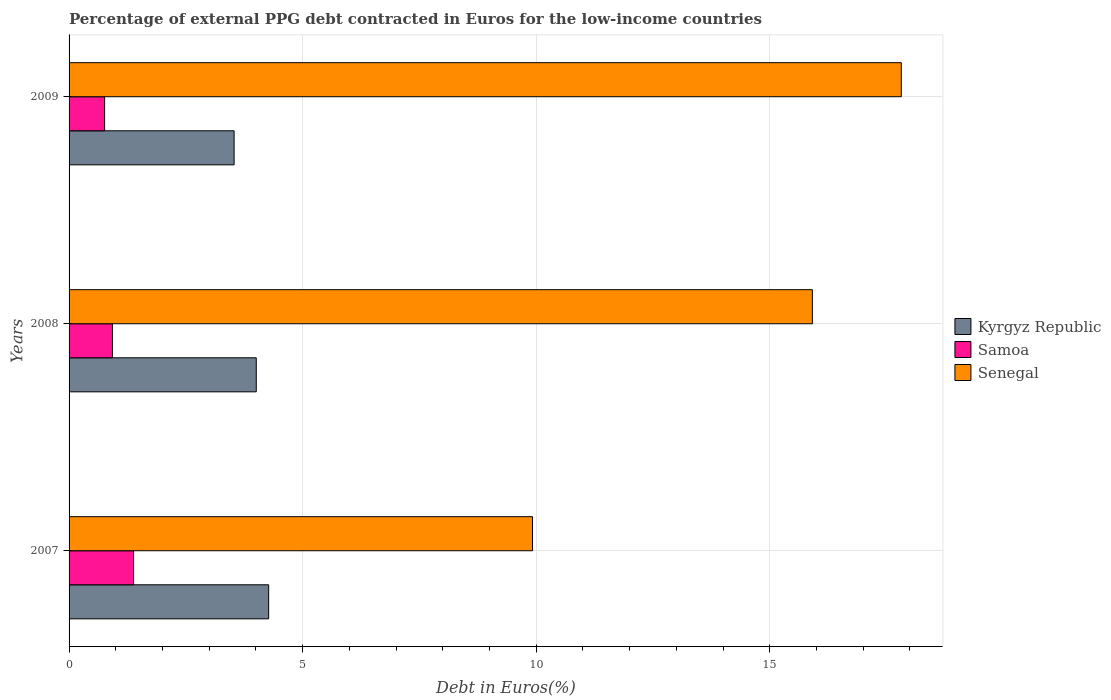How many groups of bars are there?
Offer a very short reply. 3. Are the number of bars per tick equal to the number of legend labels?
Provide a short and direct response. Yes. How many bars are there on the 2nd tick from the top?
Provide a short and direct response. 3. What is the label of the 1st group of bars from the top?
Your answer should be compact. 2009. In how many cases, is the number of bars for a given year not equal to the number of legend labels?
Offer a very short reply. 0. What is the percentage of external PPG debt contracted in Euros in Samoa in 2009?
Offer a terse response. 0.76. Across all years, what is the maximum percentage of external PPG debt contracted in Euros in Senegal?
Provide a succinct answer. 17.81. Across all years, what is the minimum percentage of external PPG debt contracted in Euros in Samoa?
Ensure brevity in your answer.  0.76. In which year was the percentage of external PPG debt contracted in Euros in Senegal minimum?
Your answer should be compact. 2007. What is the total percentage of external PPG debt contracted in Euros in Kyrgyz Republic in the graph?
Your response must be concise. 11.81. What is the difference between the percentage of external PPG debt contracted in Euros in Senegal in 2007 and that in 2008?
Make the answer very short. -5.99. What is the difference between the percentage of external PPG debt contracted in Euros in Kyrgyz Republic in 2009 and the percentage of external PPG debt contracted in Euros in Samoa in 2008?
Offer a very short reply. 2.6. What is the average percentage of external PPG debt contracted in Euros in Senegal per year?
Offer a terse response. 14.55. In the year 2007, what is the difference between the percentage of external PPG debt contracted in Euros in Senegal and percentage of external PPG debt contracted in Euros in Kyrgyz Republic?
Ensure brevity in your answer.  5.65. In how many years, is the percentage of external PPG debt contracted in Euros in Senegal greater than 5 %?
Provide a short and direct response. 3. What is the ratio of the percentage of external PPG debt contracted in Euros in Samoa in 2007 to that in 2009?
Your response must be concise. 1.82. What is the difference between the highest and the second highest percentage of external PPG debt contracted in Euros in Senegal?
Provide a succinct answer. 1.9. What is the difference between the highest and the lowest percentage of external PPG debt contracted in Euros in Samoa?
Keep it short and to the point. 0.62. In how many years, is the percentage of external PPG debt contracted in Euros in Senegal greater than the average percentage of external PPG debt contracted in Euros in Senegal taken over all years?
Ensure brevity in your answer.  2. Is the sum of the percentage of external PPG debt contracted in Euros in Kyrgyz Republic in 2007 and 2008 greater than the maximum percentage of external PPG debt contracted in Euros in Samoa across all years?
Make the answer very short. Yes. What does the 2nd bar from the top in 2009 represents?
Offer a terse response. Samoa. What does the 1st bar from the bottom in 2009 represents?
Give a very brief answer. Kyrgyz Republic. Is it the case that in every year, the sum of the percentage of external PPG debt contracted in Euros in Samoa and percentage of external PPG debt contracted in Euros in Senegal is greater than the percentage of external PPG debt contracted in Euros in Kyrgyz Republic?
Provide a succinct answer. Yes. How many bars are there?
Ensure brevity in your answer.  9. How many years are there in the graph?
Provide a short and direct response. 3. What is the difference between two consecutive major ticks on the X-axis?
Keep it short and to the point. 5. Does the graph contain grids?
Provide a succinct answer. Yes. Where does the legend appear in the graph?
Offer a very short reply. Center right. What is the title of the graph?
Provide a succinct answer. Percentage of external PPG debt contracted in Euros for the low-income countries. Does "Europe(all income levels)" appear as one of the legend labels in the graph?
Provide a succinct answer. No. What is the label or title of the X-axis?
Offer a very short reply. Debt in Euros(%). What is the label or title of the Y-axis?
Offer a terse response. Years. What is the Debt in Euros(%) in Kyrgyz Republic in 2007?
Give a very brief answer. 4.27. What is the Debt in Euros(%) in Samoa in 2007?
Your answer should be compact. 1.38. What is the Debt in Euros(%) of Senegal in 2007?
Ensure brevity in your answer.  9.92. What is the Debt in Euros(%) in Kyrgyz Republic in 2008?
Ensure brevity in your answer.  4.01. What is the Debt in Euros(%) of Samoa in 2008?
Ensure brevity in your answer.  0.93. What is the Debt in Euros(%) in Senegal in 2008?
Ensure brevity in your answer.  15.91. What is the Debt in Euros(%) in Kyrgyz Republic in 2009?
Keep it short and to the point. 3.53. What is the Debt in Euros(%) of Samoa in 2009?
Provide a short and direct response. 0.76. What is the Debt in Euros(%) of Senegal in 2009?
Offer a terse response. 17.81. Across all years, what is the maximum Debt in Euros(%) in Kyrgyz Republic?
Provide a short and direct response. 4.27. Across all years, what is the maximum Debt in Euros(%) in Samoa?
Keep it short and to the point. 1.38. Across all years, what is the maximum Debt in Euros(%) in Senegal?
Make the answer very short. 17.81. Across all years, what is the minimum Debt in Euros(%) in Kyrgyz Republic?
Give a very brief answer. 3.53. Across all years, what is the minimum Debt in Euros(%) of Samoa?
Ensure brevity in your answer.  0.76. Across all years, what is the minimum Debt in Euros(%) of Senegal?
Offer a terse response. 9.92. What is the total Debt in Euros(%) of Kyrgyz Republic in the graph?
Your response must be concise. 11.81. What is the total Debt in Euros(%) of Samoa in the graph?
Give a very brief answer. 3.07. What is the total Debt in Euros(%) in Senegal in the graph?
Ensure brevity in your answer.  43.64. What is the difference between the Debt in Euros(%) in Kyrgyz Republic in 2007 and that in 2008?
Ensure brevity in your answer.  0.27. What is the difference between the Debt in Euros(%) of Samoa in 2007 and that in 2008?
Make the answer very short. 0.45. What is the difference between the Debt in Euros(%) in Senegal in 2007 and that in 2008?
Provide a succinct answer. -5.99. What is the difference between the Debt in Euros(%) of Kyrgyz Republic in 2007 and that in 2009?
Your answer should be compact. 0.74. What is the difference between the Debt in Euros(%) of Samoa in 2007 and that in 2009?
Provide a short and direct response. 0.62. What is the difference between the Debt in Euros(%) of Senegal in 2007 and that in 2009?
Your answer should be very brief. -7.89. What is the difference between the Debt in Euros(%) of Kyrgyz Republic in 2008 and that in 2009?
Give a very brief answer. 0.47. What is the difference between the Debt in Euros(%) in Samoa in 2008 and that in 2009?
Keep it short and to the point. 0.17. What is the difference between the Debt in Euros(%) of Senegal in 2008 and that in 2009?
Provide a succinct answer. -1.9. What is the difference between the Debt in Euros(%) in Kyrgyz Republic in 2007 and the Debt in Euros(%) in Samoa in 2008?
Offer a terse response. 3.34. What is the difference between the Debt in Euros(%) of Kyrgyz Republic in 2007 and the Debt in Euros(%) of Senegal in 2008?
Make the answer very short. -11.64. What is the difference between the Debt in Euros(%) in Samoa in 2007 and the Debt in Euros(%) in Senegal in 2008?
Your response must be concise. -14.53. What is the difference between the Debt in Euros(%) of Kyrgyz Republic in 2007 and the Debt in Euros(%) of Samoa in 2009?
Provide a short and direct response. 3.51. What is the difference between the Debt in Euros(%) in Kyrgyz Republic in 2007 and the Debt in Euros(%) in Senegal in 2009?
Ensure brevity in your answer.  -13.54. What is the difference between the Debt in Euros(%) of Samoa in 2007 and the Debt in Euros(%) of Senegal in 2009?
Provide a short and direct response. -16.43. What is the difference between the Debt in Euros(%) of Kyrgyz Republic in 2008 and the Debt in Euros(%) of Samoa in 2009?
Provide a short and direct response. 3.25. What is the difference between the Debt in Euros(%) of Kyrgyz Republic in 2008 and the Debt in Euros(%) of Senegal in 2009?
Your response must be concise. -13.81. What is the difference between the Debt in Euros(%) of Samoa in 2008 and the Debt in Euros(%) of Senegal in 2009?
Give a very brief answer. -16.89. What is the average Debt in Euros(%) of Kyrgyz Republic per year?
Ensure brevity in your answer.  3.94. What is the average Debt in Euros(%) of Samoa per year?
Keep it short and to the point. 1.02. What is the average Debt in Euros(%) of Senegal per year?
Keep it short and to the point. 14.55. In the year 2007, what is the difference between the Debt in Euros(%) of Kyrgyz Republic and Debt in Euros(%) of Samoa?
Provide a short and direct response. 2.89. In the year 2007, what is the difference between the Debt in Euros(%) of Kyrgyz Republic and Debt in Euros(%) of Senegal?
Your answer should be compact. -5.65. In the year 2007, what is the difference between the Debt in Euros(%) of Samoa and Debt in Euros(%) of Senegal?
Give a very brief answer. -8.54. In the year 2008, what is the difference between the Debt in Euros(%) in Kyrgyz Republic and Debt in Euros(%) in Samoa?
Ensure brevity in your answer.  3.08. In the year 2008, what is the difference between the Debt in Euros(%) of Kyrgyz Republic and Debt in Euros(%) of Senegal?
Offer a very short reply. -11.9. In the year 2008, what is the difference between the Debt in Euros(%) in Samoa and Debt in Euros(%) in Senegal?
Offer a terse response. -14.98. In the year 2009, what is the difference between the Debt in Euros(%) in Kyrgyz Republic and Debt in Euros(%) in Samoa?
Make the answer very short. 2.77. In the year 2009, what is the difference between the Debt in Euros(%) in Kyrgyz Republic and Debt in Euros(%) in Senegal?
Give a very brief answer. -14.28. In the year 2009, what is the difference between the Debt in Euros(%) of Samoa and Debt in Euros(%) of Senegal?
Make the answer very short. -17.05. What is the ratio of the Debt in Euros(%) of Kyrgyz Republic in 2007 to that in 2008?
Your response must be concise. 1.07. What is the ratio of the Debt in Euros(%) of Samoa in 2007 to that in 2008?
Provide a succinct answer. 1.49. What is the ratio of the Debt in Euros(%) in Senegal in 2007 to that in 2008?
Give a very brief answer. 0.62. What is the ratio of the Debt in Euros(%) in Kyrgyz Republic in 2007 to that in 2009?
Offer a very short reply. 1.21. What is the ratio of the Debt in Euros(%) in Samoa in 2007 to that in 2009?
Ensure brevity in your answer.  1.82. What is the ratio of the Debt in Euros(%) of Senegal in 2007 to that in 2009?
Provide a short and direct response. 0.56. What is the ratio of the Debt in Euros(%) in Kyrgyz Republic in 2008 to that in 2009?
Offer a very short reply. 1.13. What is the ratio of the Debt in Euros(%) of Samoa in 2008 to that in 2009?
Your answer should be compact. 1.22. What is the ratio of the Debt in Euros(%) of Senegal in 2008 to that in 2009?
Your answer should be compact. 0.89. What is the difference between the highest and the second highest Debt in Euros(%) of Kyrgyz Republic?
Offer a very short reply. 0.27. What is the difference between the highest and the second highest Debt in Euros(%) of Samoa?
Provide a succinct answer. 0.45. What is the difference between the highest and the second highest Debt in Euros(%) of Senegal?
Offer a terse response. 1.9. What is the difference between the highest and the lowest Debt in Euros(%) of Kyrgyz Republic?
Your answer should be very brief. 0.74. What is the difference between the highest and the lowest Debt in Euros(%) in Samoa?
Your answer should be very brief. 0.62. What is the difference between the highest and the lowest Debt in Euros(%) in Senegal?
Your answer should be very brief. 7.89. 